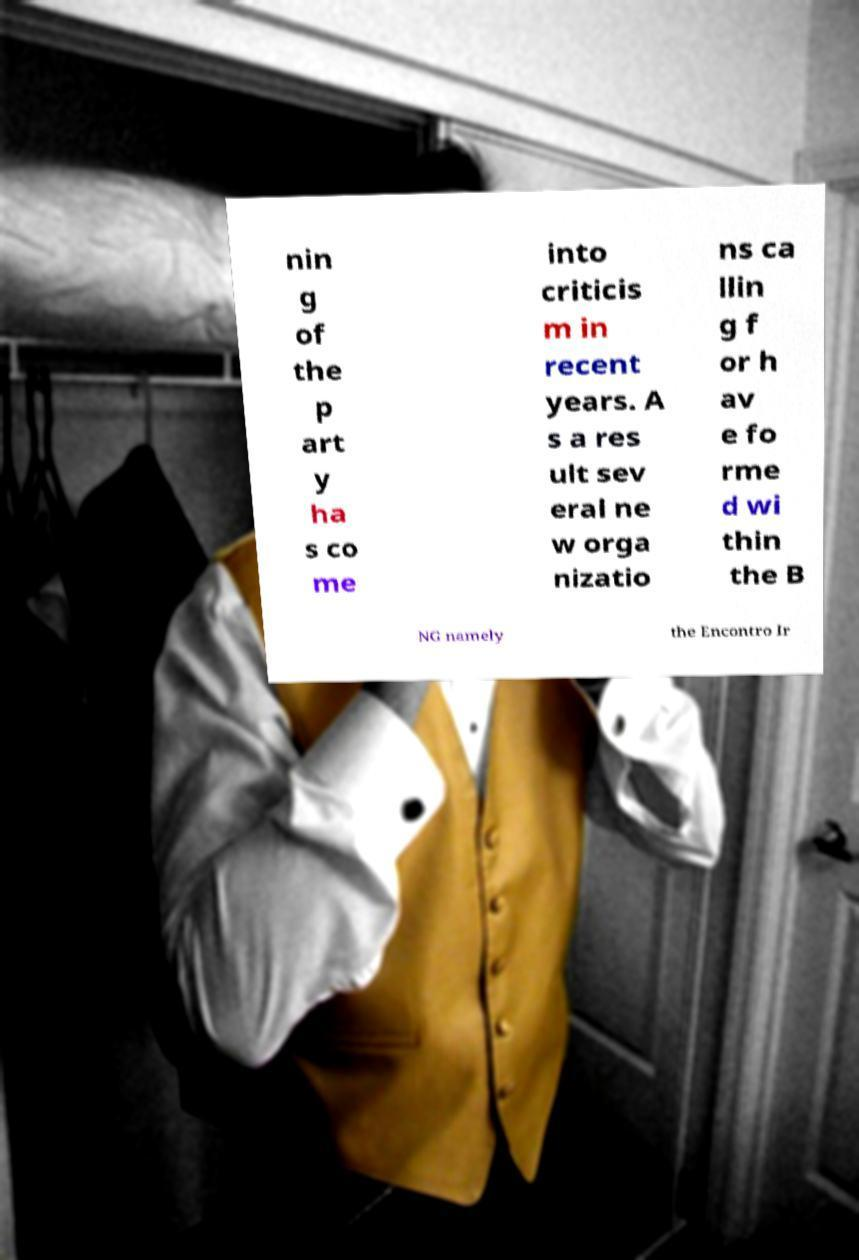For documentation purposes, I need the text within this image transcribed. Could you provide that? nin g of the p art y ha s co me into criticis m in recent years. A s a res ult sev eral ne w orga nizatio ns ca llin g f or h av e fo rme d wi thin the B NG namely the Encontro Ir 